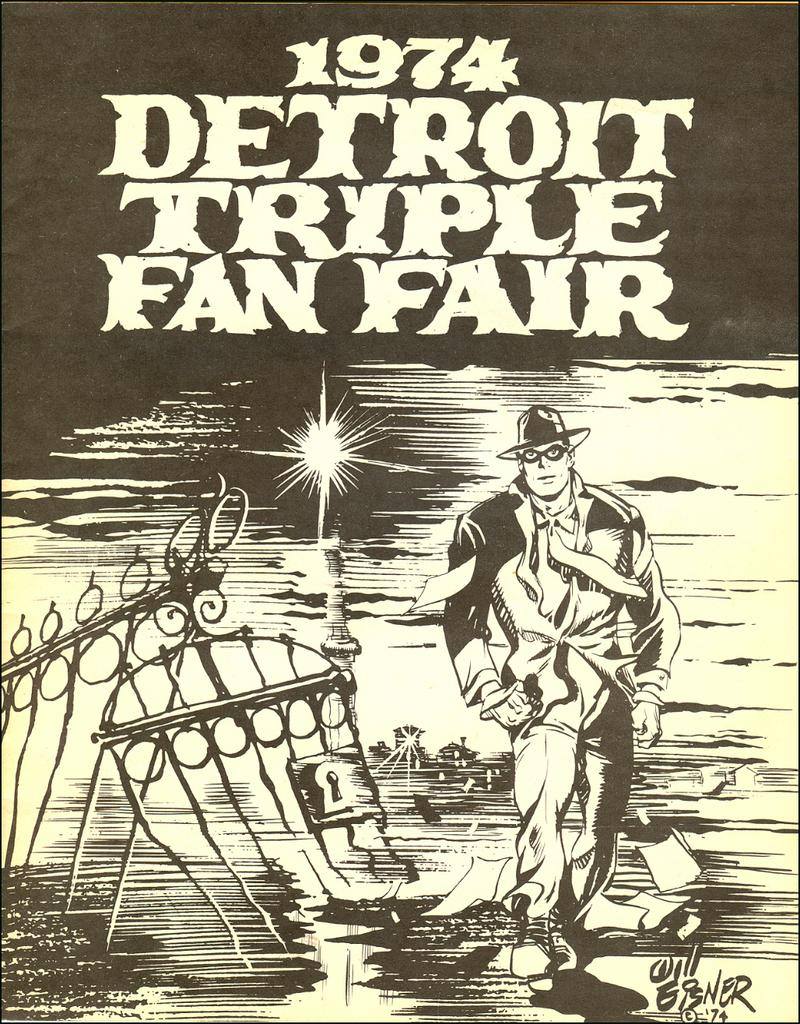What type of visual is the image? The image is a poster. What can be seen on the poster? There are objects, numbers, and letters depicted on the poster. Can you describe the man in the image? The man in the image is wearing a hat and goggles. How much debt does the man owe in the image? There is no mention of debt in the image; it only shows a man wearing a hat and goggles. What is the answer to the question posed by the man in the image? There is no question or answer present in the image; it only shows a man wearing a hat and goggles. 